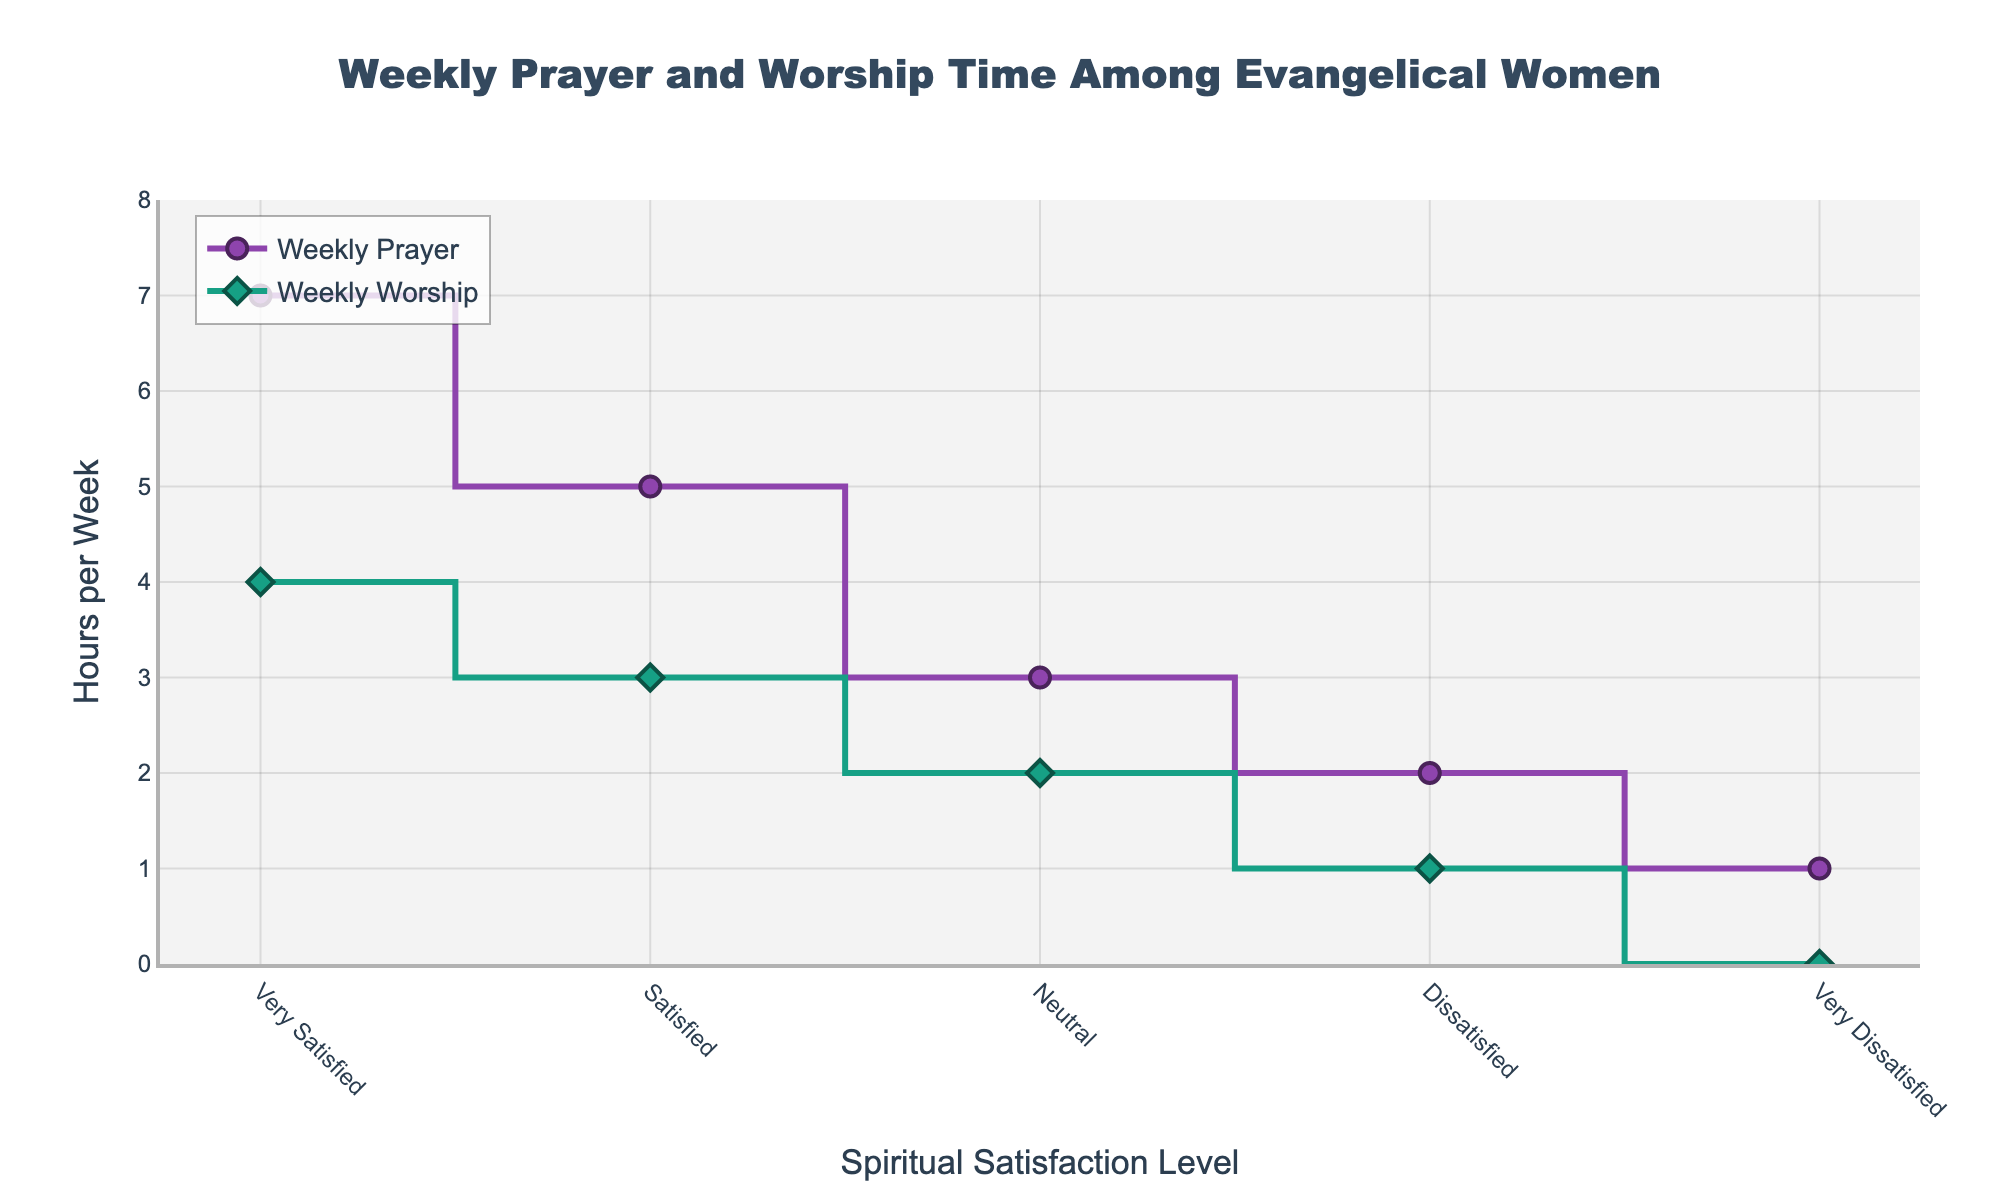What is the title of the plot? The title is usually displayed at the top of the plot. It clearly states the subject of the figure.
Answer: Weekly Prayer and Worship Time Among Evangelical Women How many levels of spiritual satisfaction are shown in the figure? To find the number of levels, we count the distinct categories along the x-axis. Each category represents a level of spiritual satisfaction.
Answer: 5 What is the weekly worship time for women who are 'Very Satisfied'? Look at the data point aligned with the 'Very Satisfied' category along the x-axis and note the corresponding value on the y-axis for Worship Time.
Answer: 4 hours How does the prayer time compare between women who are 'Neutral' and those who are 'Dissatisfied'? Locate the data points for Prayer Time on the 'Neutral' and 'Dissatisfied' categories along the x-axis and compare their y-values.
Answer: Neutral: 3 hours, Dissatisfied: 2 hours What is the difference in weekly worship time between those who are 'Satisfied' and 'Very Dissatisfied'? Check the y-values for Worship Time at the 'Satisfied' and 'Very Dissatisfied' categories and subtract the smaller value from the larger one.
Answer: 3 - 0 = 3 hours Which spiritual satisfaction level has the highest weekly prayer time? Compare the y-values for Prayer Time across all satisfaction levels and identify the highest value and its corresponding category.
Answer: Very Satisfied What is the combined weekly prayer and worship time for 'Satisfied' women? Add the y-values for Prayer Time and Worship Time at the 'Satisfied' category.
Answer: 5 + 3 = 8 hours Is there a linear trend in weekly worship time as spiritual satisfaction decreases? Observe the data points for Worship Time from 'Very Satisfied' to 'Very Dissatisfied' and see if they follow a consistent increasing or decreasing pattern.
Answer: Yes, it decreases linearly How much more time per week do 'Very Satisfied' women spend on prayer compared to 'Very Dissatisfied' women? Subtract the y-value for Prayer Time at the 'Very Dissatisfied' category from the y-value at the 'Very Satisfied' category.
Answer: 7 - 1 = 6 hours For which categories are the prayer and worship times exactly proportional? Compare the ratio of y-values (Prayer/Worship) across all categories and see if any have the same ratio.
Answer: None are exactly proportional 